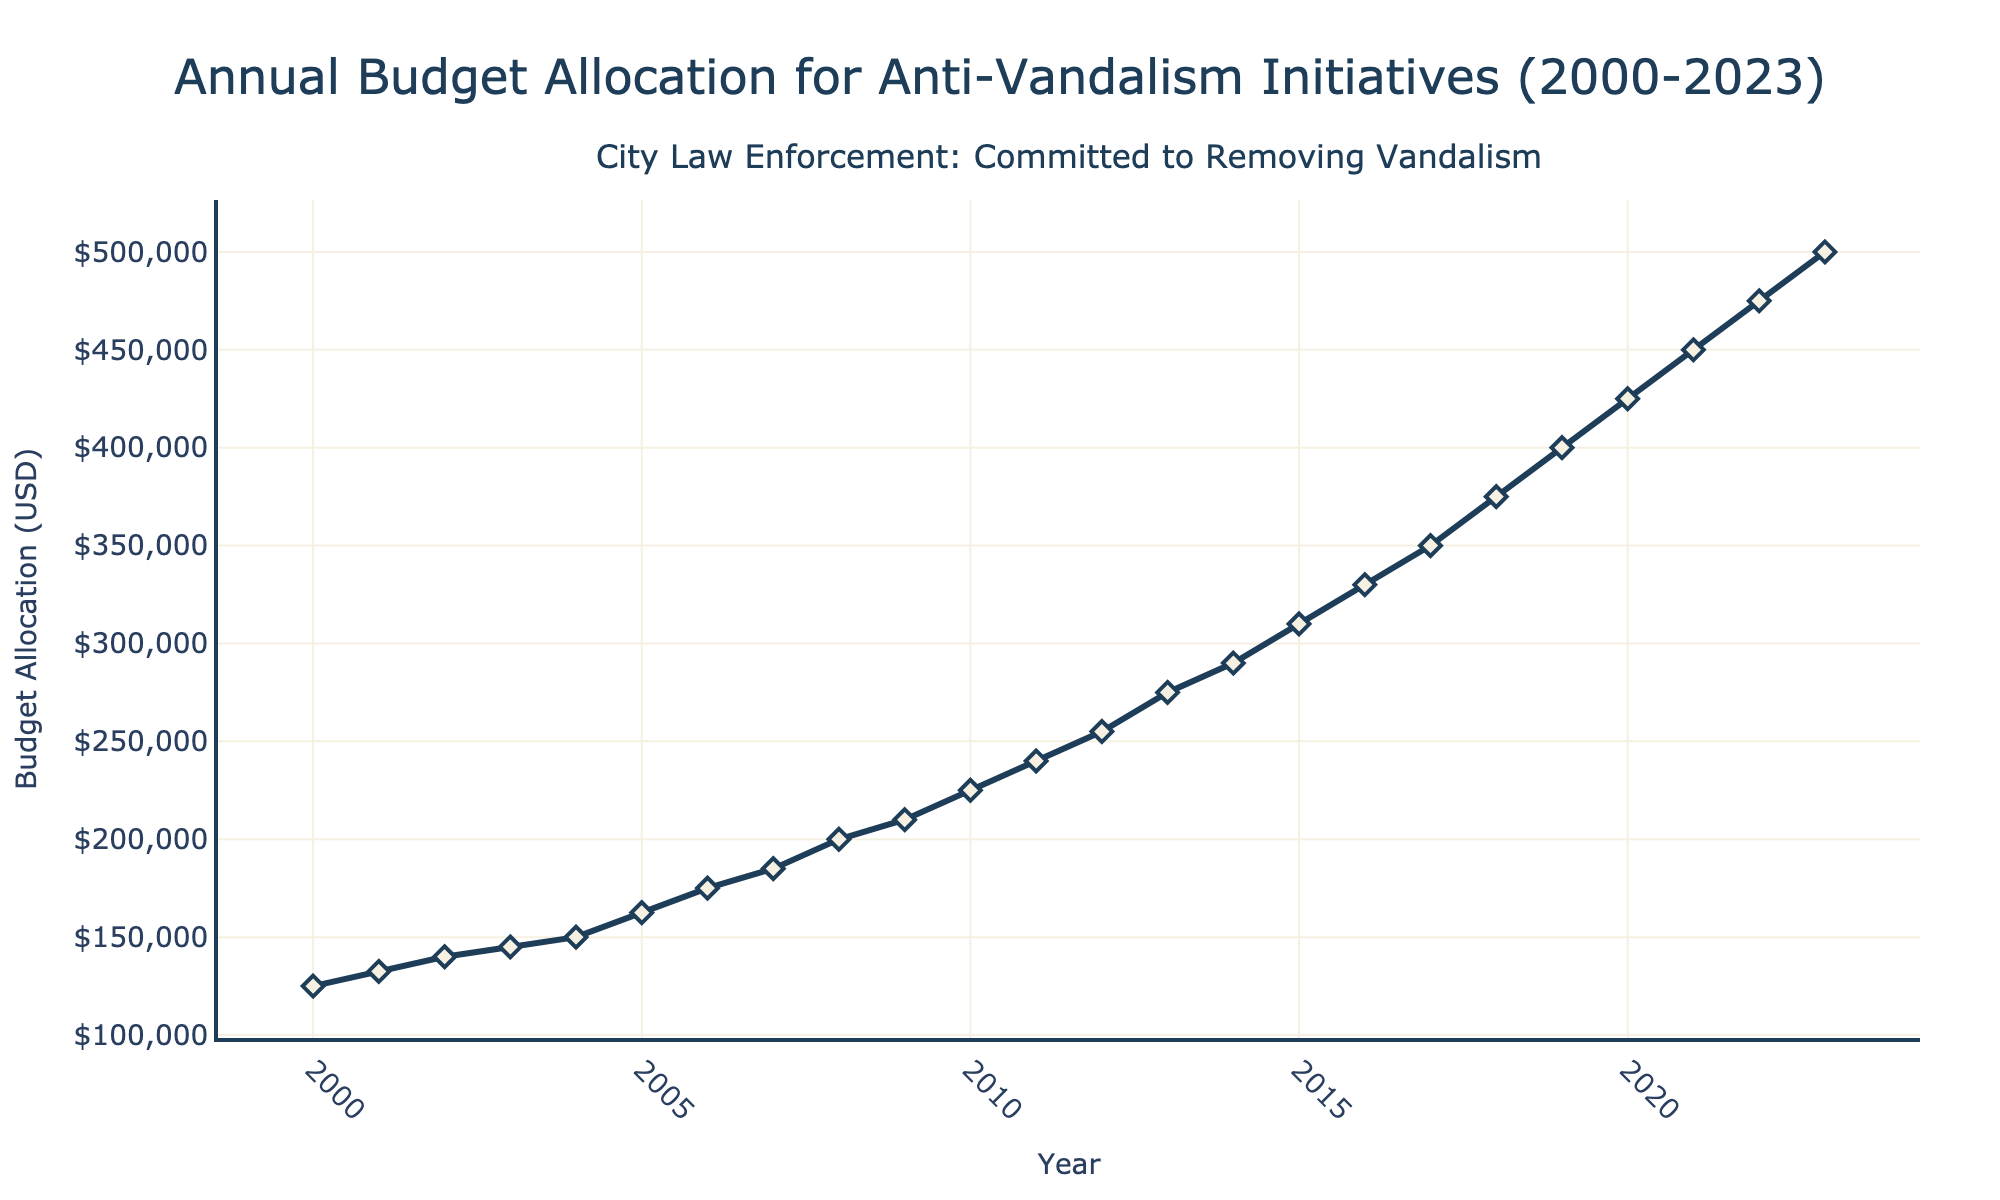How has the budget allocation for anti-vandalism initiatives changed from 2000 to 2023? First, look at the start and end points of the line in the figure. The budget in 2000 is $125,000, and by 2023, it has increased to $500,000. Calculate the change as $500,000 - $125,000.
Answer: Increased by $375,000 When did the budget allocation first reach $200,000? Look for the year on the x-axis where the y-axis value first hits $200,000. The budget allocation reaches $200,000 in 2008.
Answer: 2008 Which year saw the highest increase in budget allocation compared to the previous year? Calculate the year-over-year increases and compare them. For example, from 2000 to 2001, the increase was $132,500 - $125,000 = $7,500. The highest jump is from 2018 to 2019, where the increase is $400,000 - $375,000 = $25,000.
Answer: 2019 What is the average budget allocation for the years 2000 to 2010? Sum the budget allocations from 2000 to 2010 and then divide by the number of years (11). The sum is $125,000 + $132,500 + $140,000 + $145,000 + $150,000 + $162,500 + $175,000 + $185,000 + $200,000 + $210,000 + $225,000 = $1,750,000. Average is $1,750,000 / 11.
Answer: $159,091 How many times did the budget exceed $300,000 over the given period? Identify the years where the budget allocation has exceeded $300,000 by looking at the y-axis values and counting those instances. The budget exceeds $300,000 in 2015, 2016, 2017, 2018, 2019, 2020, 2021, 2022, and 2023, which are 9 times.
Answer: 9 By how much did the budget allocation increase from 2010 to 2023? Subtract the budget allocation in 2010 from the allocation in 2023. The calculation is $500,000 - $225,000.
Answer: $275,000 Which years saw a budget allocation that was double the allocation in 2000? Double the 2000 allocation is 2 * $125,000 = $250,000. Check which years have budgets equal to or higher than this amount. 2011 is the first such year with an allocation of $240,000. Comparing further, 2012 and beyond have allocations exceeding double of 2000.
Answer: 2012 onward What was the approximate budget allocation in the mid-point (median) year of 2000 to 2023? The median year is between 2011 and 2012, so average the allocations of these two years. ($240,000 + $255,000) / 2 = $247,500.
Answer: $247,500 Compare the budget allocation growth trends from 2000-2010 and 2010-2020. From 2000 to 2010, the budget grew from $125,000 to $225,000, an increase of $100,000 over 10 years. From 2010 to 2020, it grew from $225,000 to $425,000, an increase of $200,000 over another 10 years. This shows a faster growth rate in the latter period.
Answer: Faster growth from 2010-2020 